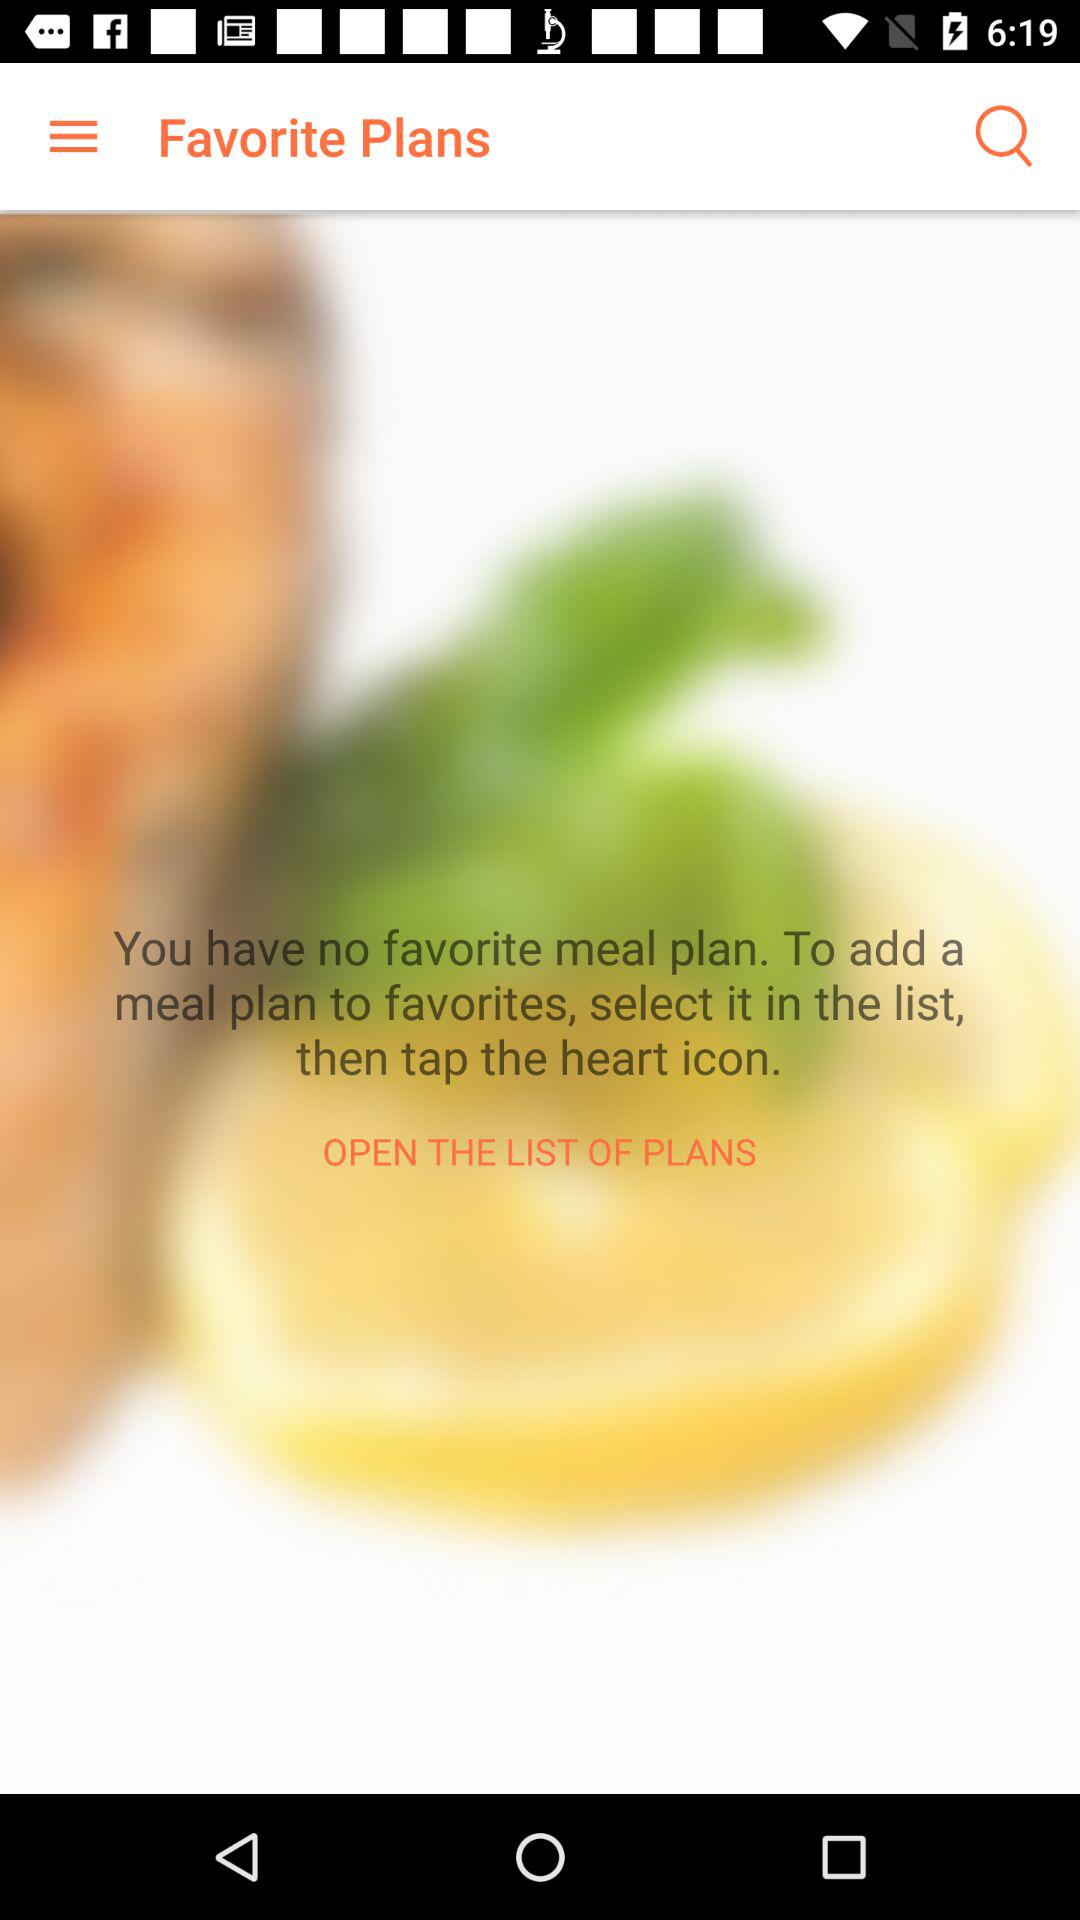How many actions can I take to add a meal plan to favorites?
Answer the question using a single word or phrase. 2 